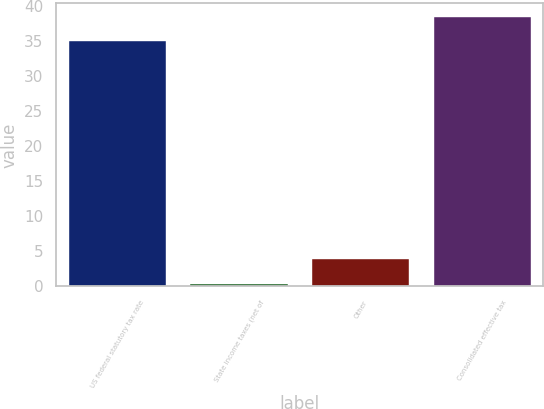Convert chart. <chart><loc_0><loc_0><loc_500><loc_500><bar_chart><fcel>US federal statutory tax rate<fcel>State income taxes (net of<fcel>Other<fcel>Consolidated effective tax<nl><fcel>35<fcel>0.4<fcel>3.9<fcel>38.5<nl></chart> 